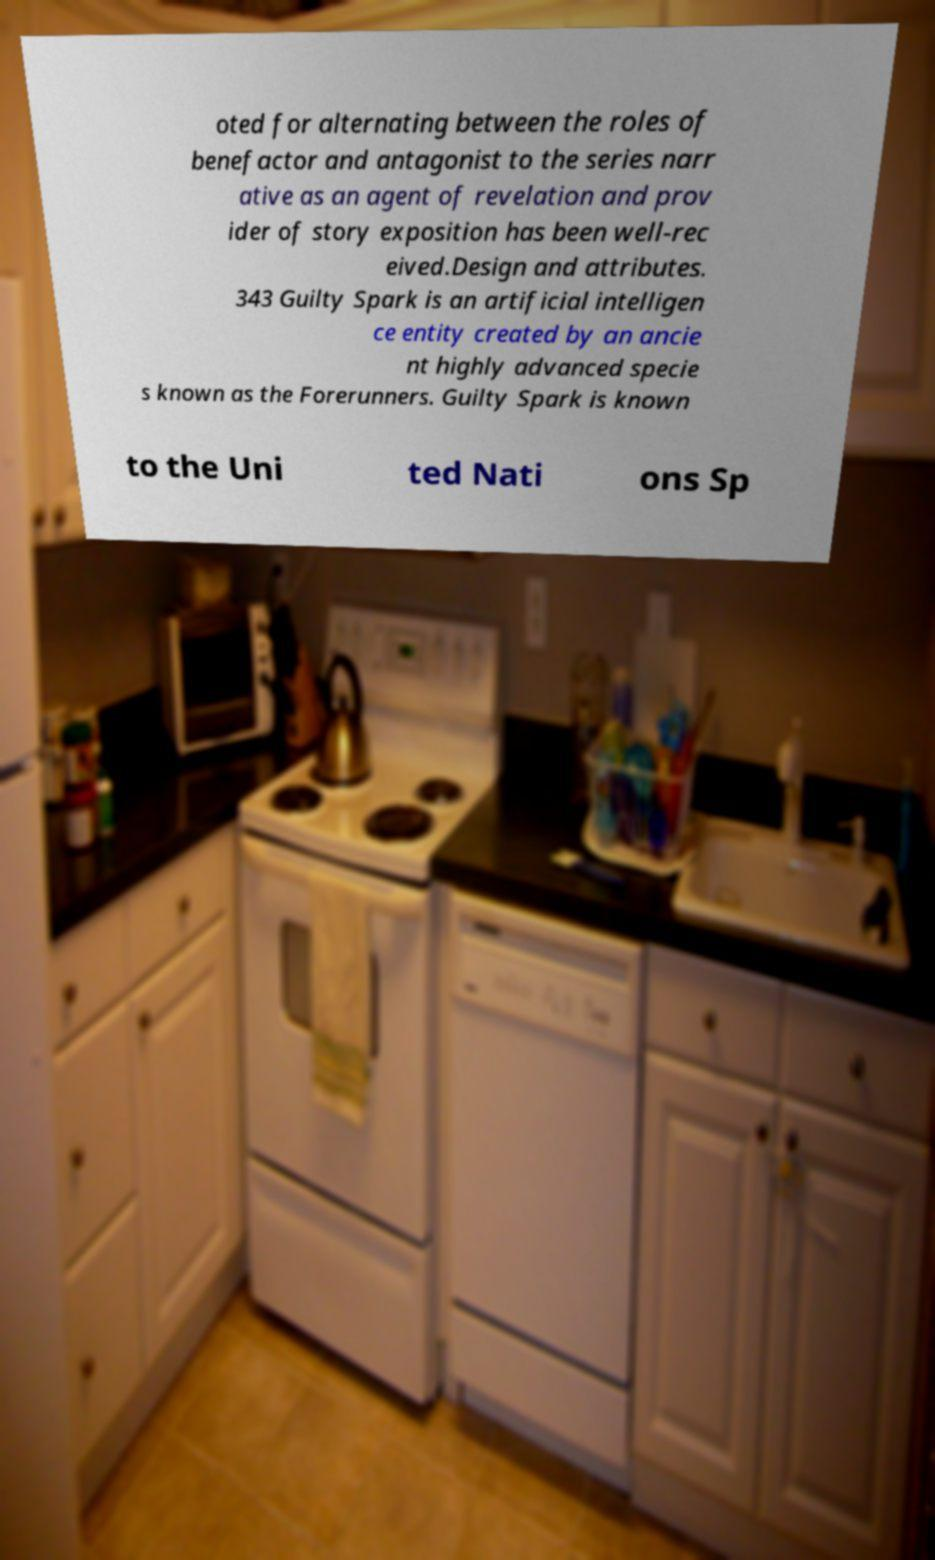I need the written content from this picture converted into text. Can you do that? oted for alternating between the roles of benefactor and antagonist to the series narr ative as an agent of revelation and prov ider of story exposition has been well-rec eived.Design and attributes. 343 Guilty Spark is an artificial intelligen ce entity created by an ancie nt highly advanced specie s known as the Forerunners. Guilty Spark is known to the Uni ted Nati ons Sp 